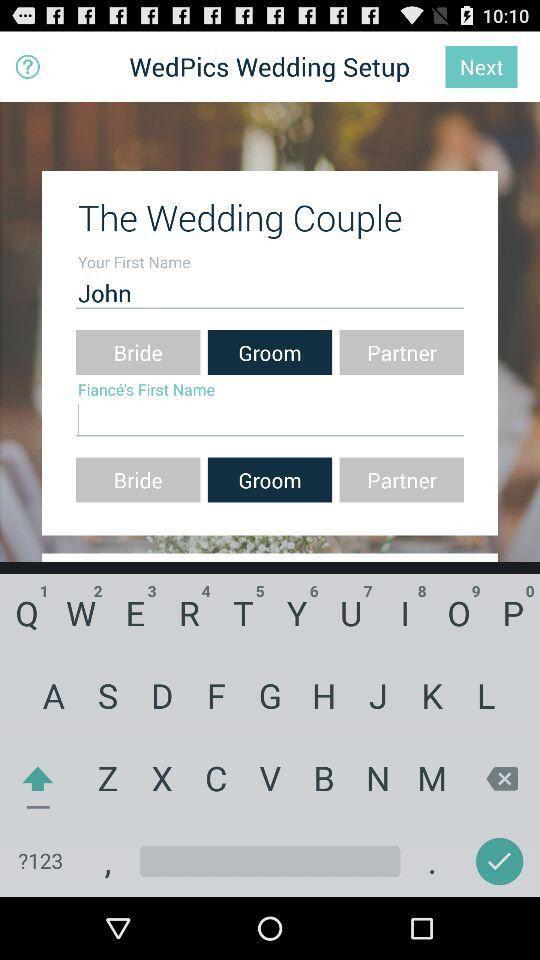What informations can we edit?
When the provided information is insufficient, respond with <no answer>. <no answer> 